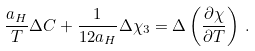<formula> <loc_0><loc_0><loc_500><loc_500>\frac { a _ { H } } { T } \Delta C + \frac { 1 } { 1 2 a _ { H } } \Delta { \chi } _ { 3 } = \Delta \left ( \frac { \partial { \chi } } { \partial T } \right ) \, .</formula> 